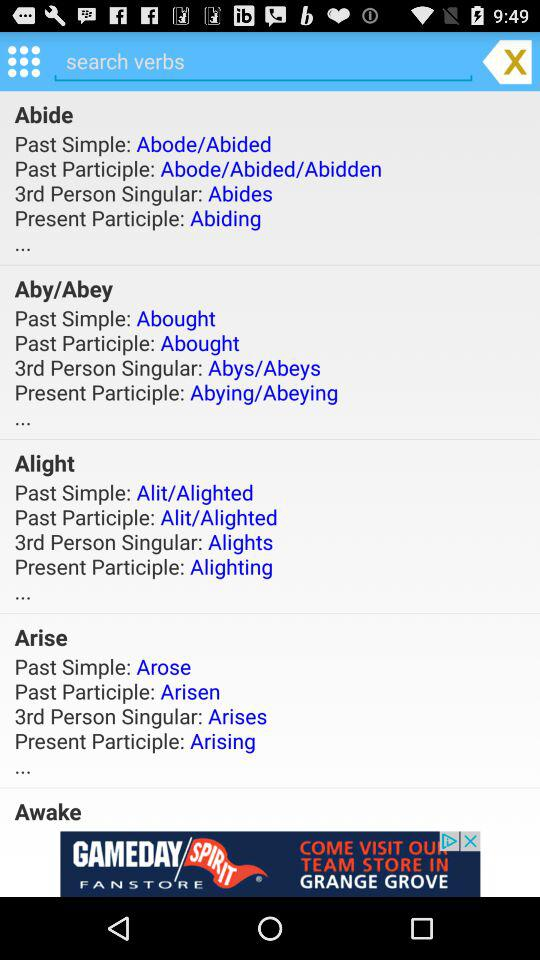What word's present participle is "Alighting"? The word is "Alight". 